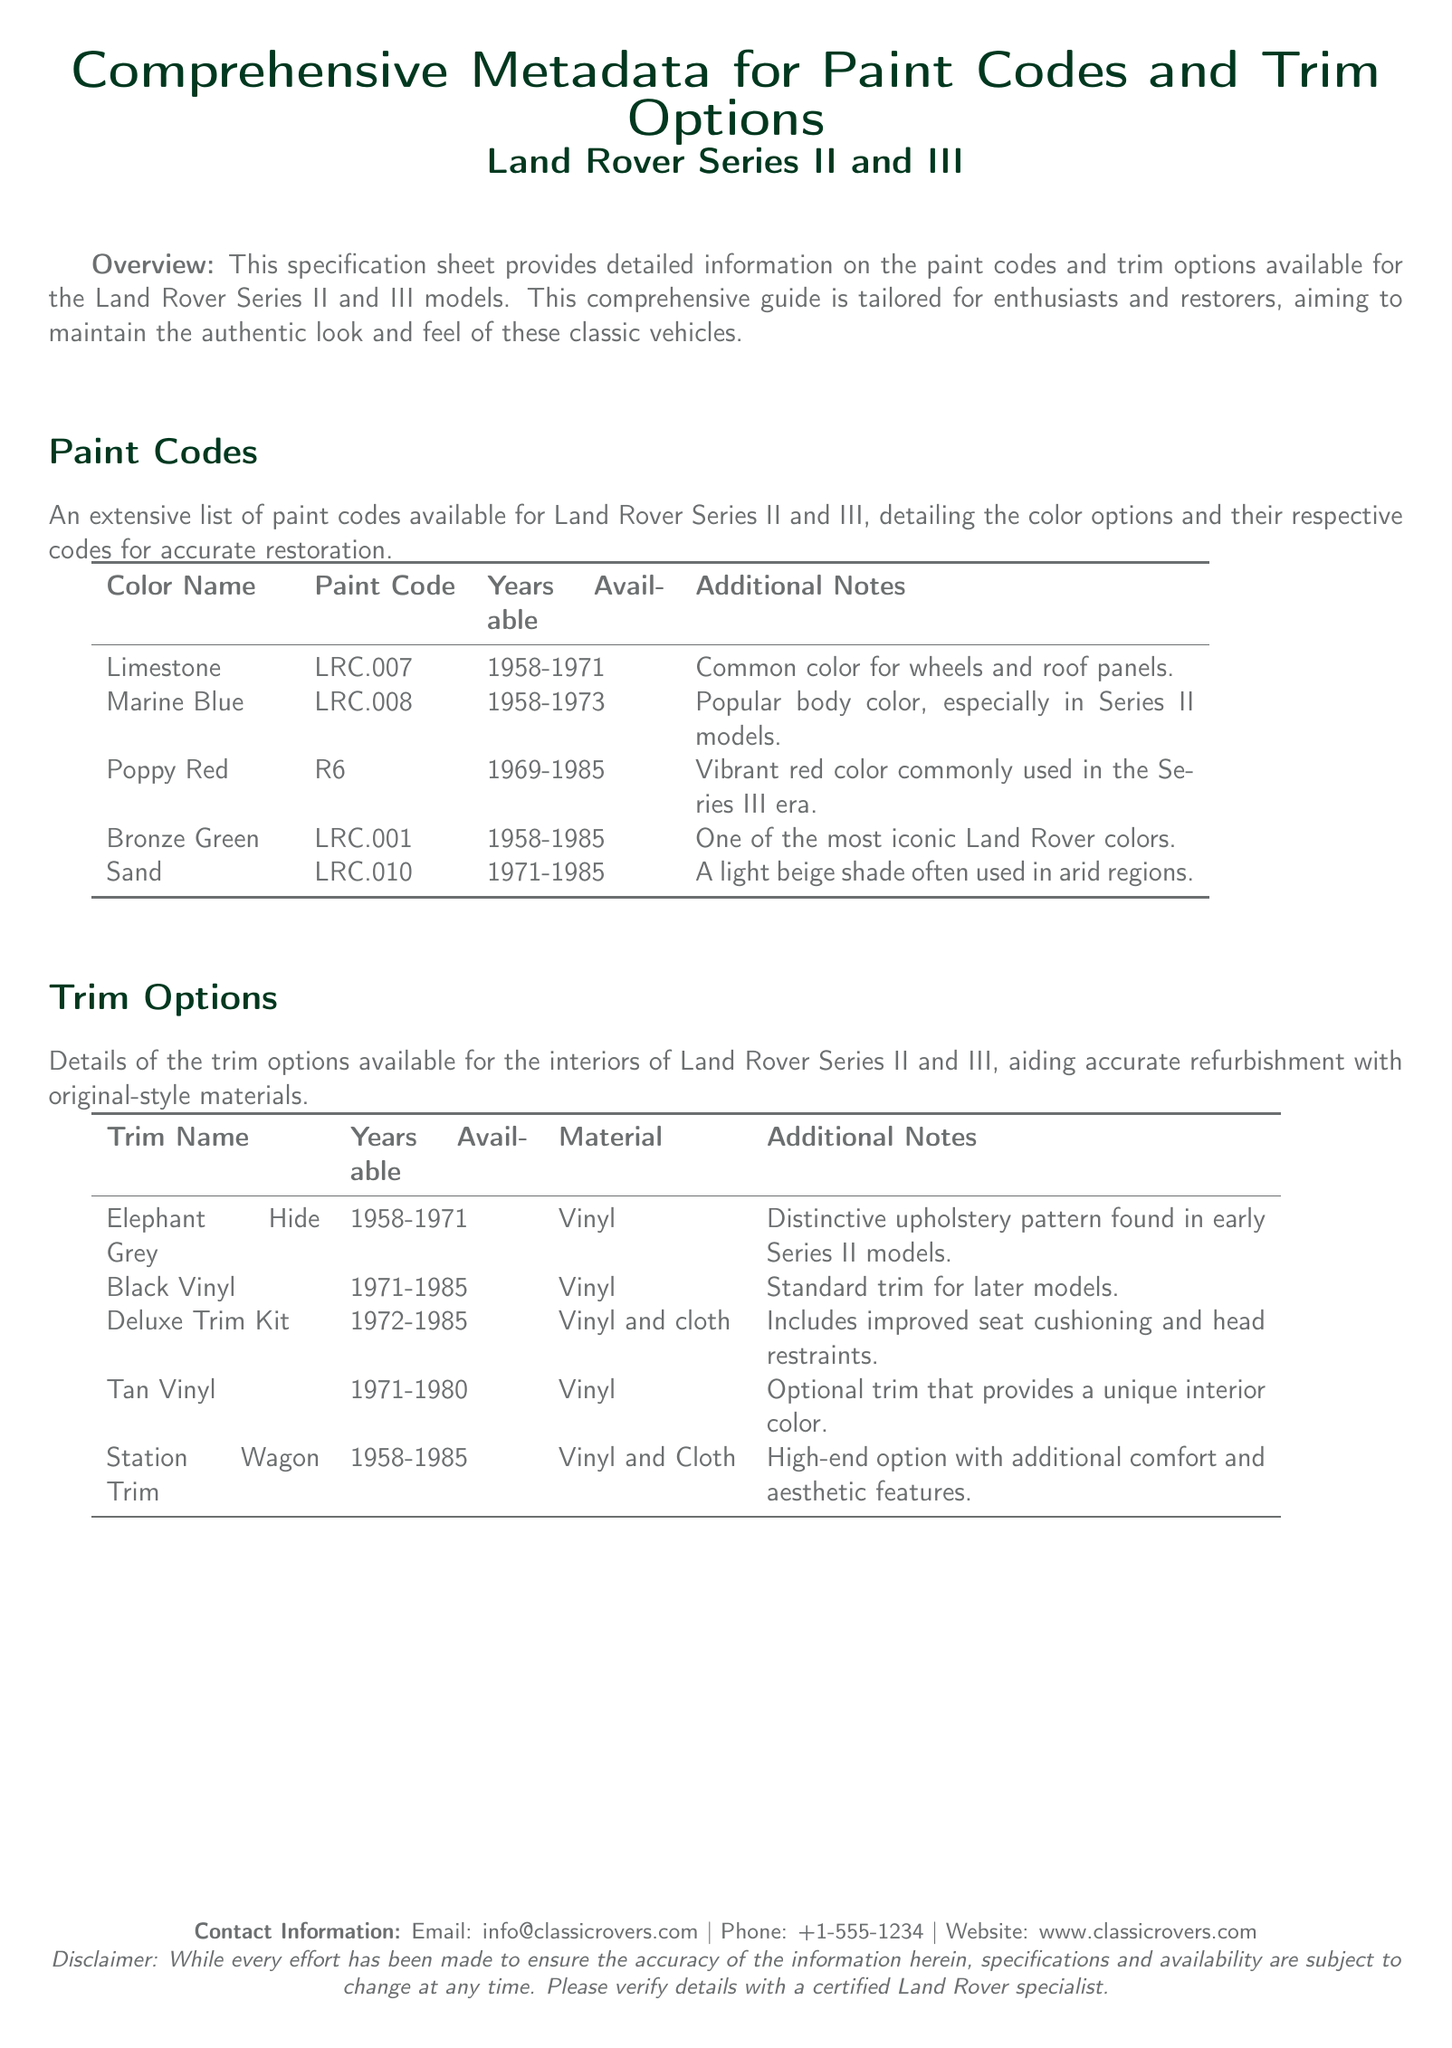What is the paint code for Limestone? The document provides a table of paint codes, where Limestone is listed with the paint code LRC.007.
Answer: LRC.007 Which years was Marine Blue available? The paint codes section specifies that Marine Blue was available from 1958 to 1973.
Answer: 1958-1973 What material is used for the Deluxe Trim Kit? The trim options section indicates that the Deluxe Trim Kit is made from vinyl and cloth.
Answer: Vinyl and cloth How many colors are listed under Paint Codes? The number of colors can be determined by counting the entries in the paint codes table, which lists five colors.
Answer: Five Which trim option is noted for its distinctive upholstery pattern? The trim options table indicates that Elephant Hide Grey has a distinctive upholstery pattern found in early Series II models.
Answer: Elephant Hide Grey What is the popular body color mentioned for Series II models? The document notes Marine Blue as a popular body color for Series II models.
Answer: Marine Blue What is the contact information email provided in the document? The document includes a section for contact information, listing the email as info@classicrovers.com.
Answer: info@classicrovers.com What trim option offers additional comfort and aesthetic features? According to the trim options section, the Station Wagon Trim provides additional comfort and aesthetic features.
Answer: Station Wagon Trim Which paint code corresponds to the color Poppy Red? The paint code table specifies that Poppy Red corresponds to the paint code R6.
Answer: R6 